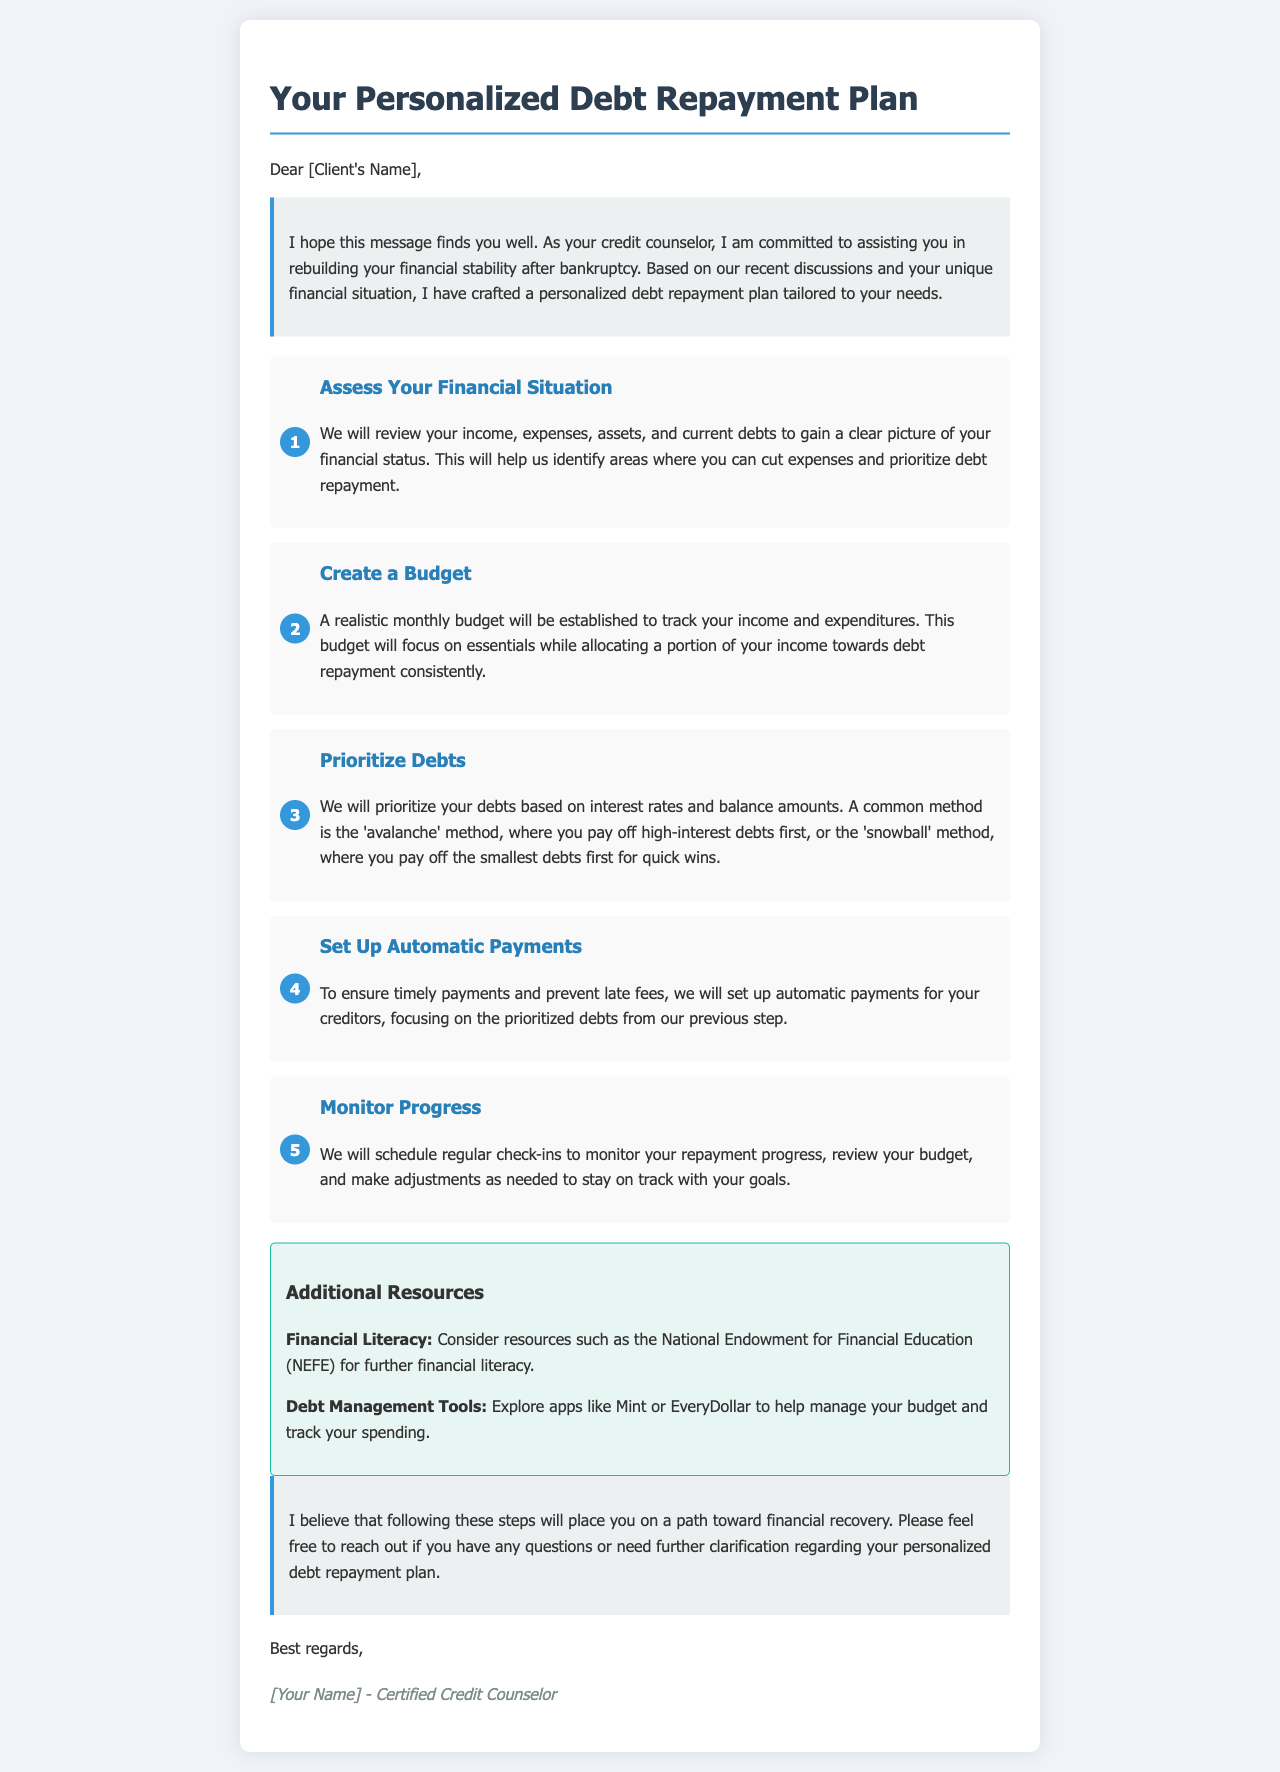What is the title of the document? The title appears in the header of the document, which is "Your Personalized Debt Repayment Plan."
Answer: Your Personalized Debt Repayment Plan Who is the intended audience of the document? The document addresses a specific person and offers help, indicating it is intended for "Client."
Answer: Client What is the first step in the debt repayment plan? The first step is outlined in the steps section, where it states "Assess Your Financial Situation."
Answer: Assess Your Financial Situation What method of prioritizing debts is mentioned in the document? The document references two common methods to prioritize debts, one of which is the "avalanche" method.
Answer: avalanche Which app is suggested for managing a budget? The document lists a specific app for budget management, which is "Mint."
Answer: Mint How often will progress be monitored according to the plan? The plan mentions "regular check-ins" for monitoring progress, although it does not specify a frequency.
Answer: regular check-ins What final advice does the credit counselor provide? The counselor expresses that they believe these steps will lead to financial recovery as stated in the conclusion section.
Answer: financial recovery Who signs the document? The document concludes with a signature from a "Certified Credit Counselor," indicating the author's role.
Answer: Certified Credit Counselor 